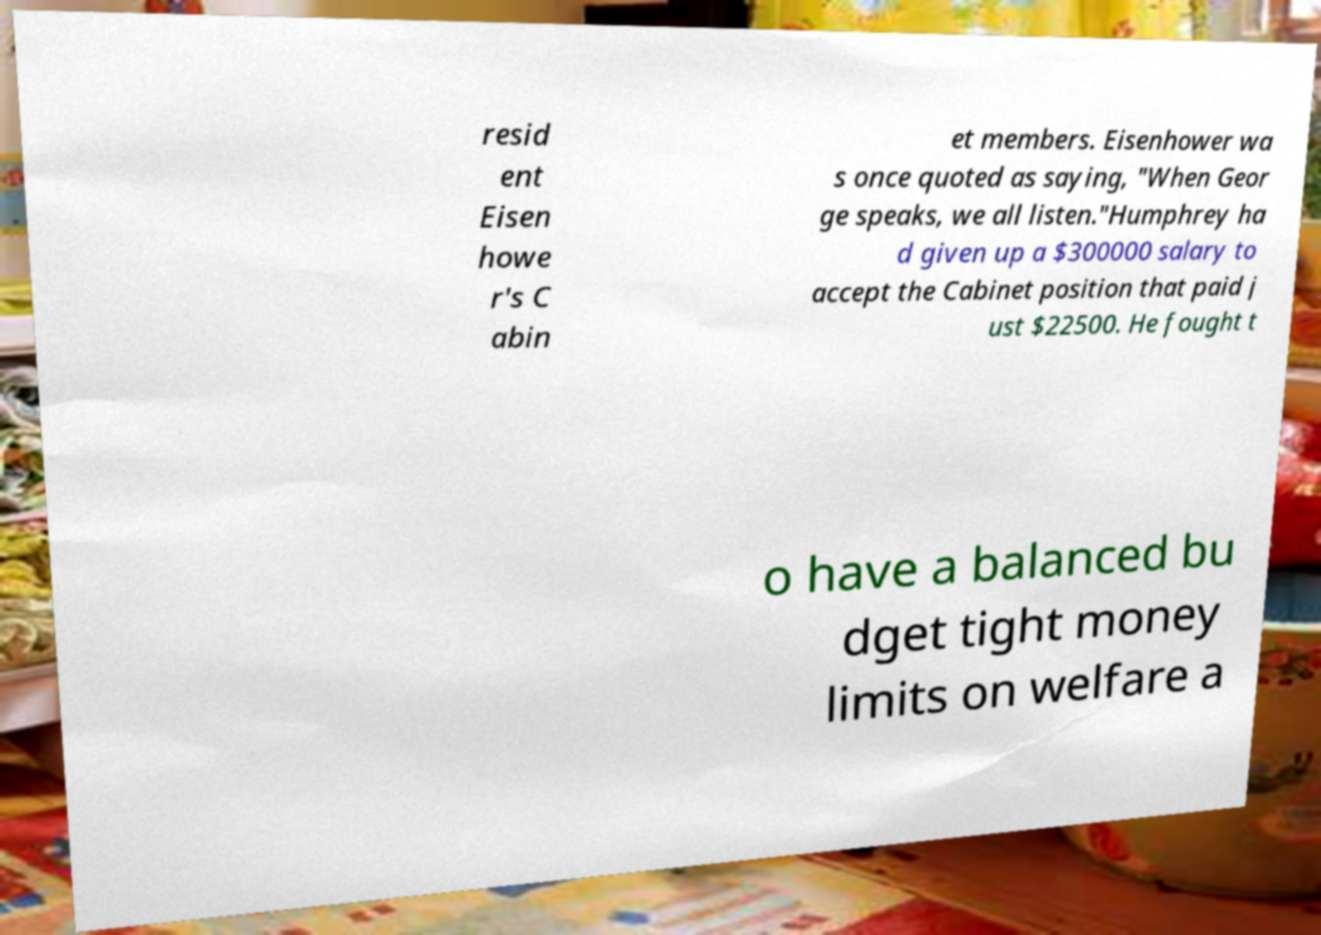Can you accurately transcribe the text from the provided image for me? resid ent Eisen howe r's C abin et members. Eisenhower wa s once quoted as saying, "When Geor ge speaks, we all listen."Humphrey ha d given up a $300000 salary to accept the Cabinet position that paid j ust $22500. He fought t o have a balanced bu dget tight money limits on welfare a 